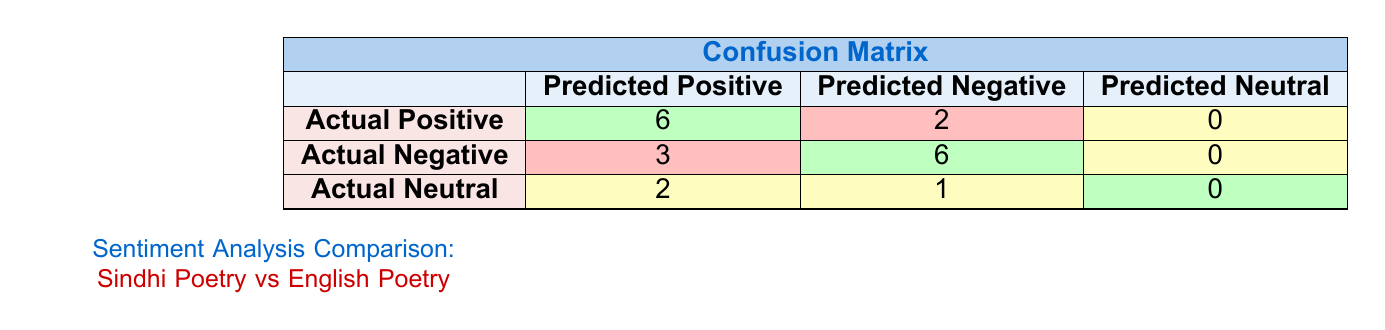What is the total number of actual positive sentiments in the confusion matrix? The actual positive row shows there are 6 predicted as positive and 2 predicted as negative. To find the total actual positives, we sum these values: 6 + 2 = 8.
Answer: 8 What number of actual negatives were predicted as positive? The actual negative row has 3 predicted as positive, which is directly provided in the table.
Answer: 3 How many sentiments were predicted as neutral? The matrix does not explicitly list neutral predictions for the actual categories, but they are zero for actual positive and actual negative, plus 2 for actual neutral. Therefore, total neutral predictions equal: 0 + 0 + 2 = 2.
Answer: 2 Is the number of actual positive sentiments greater than the number of actual neutral sentiments? There are 8 actual positive sentiments (6 + 2) and 3 actual neutral sentiments (2 + 1). Since 8 is greater than 3, the statement is true.
Answer: Yes What percentage of actual positive sentiments were correctly predicted as positive? To find the percentage of correct predictions, divide the correct positives (6) by total actual positives (8) and multiply by 100: (6 / 8) * 100 = 75%.
Answer: 75% How many total sentiments are classified as positive across all categories? From the table, the positive sentiments in each row are 6 (actual positive) + 3 (actual negative) + 2 (actual neutral) = 11 in total.
Answer: 11 What is the difference between the predicted positive counts for actual positives and actual negatives? From the table, actual positives have 6 predicted as positive, and actual negatives have 3 predicted as positive. The difference is 6 - 3 = 3.
Answer: 3 Are there more predicted positives for actual positive sentiments than actual negatives? Actual positives have 6 predicted positive sentiments whereas actual negatives have 3. Comparing these counts, 6 is greater than 3.
Answer: Yes How many more actual negatives are predicted as negative than neutrals are predicted as positive? From the table, there are 6 actual negatives predicted as negative. For actual neutral, there are 2 predicted as positive. The difference is 6 - 2 = 4.
Answer: 4 